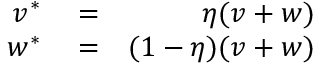<formula> <loc_0><loc_0><loc_500><loc_500>\begin{array} { r l r } { v ^ { * } } & = } & { \eta ( v + w ) } \\ { w ^ { * } } & = } & { ( 1 - \eta ) ( v + w ) } \end{array}</formula> 